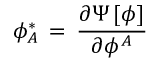<formula> <loc_0><loc_0><loc_500><loc_500>\phi _ { A } ^ { \ast } \, = \, { \frac { \partial \Psi \, [ \phi ] } { \partial \phi ^ { A } } }</formula> 